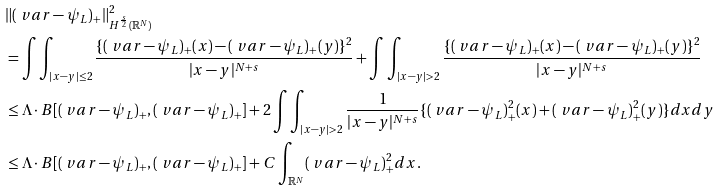<formula> <loc_0><loc_0><loc_500><loc_500>& \| ( \ v a r - \psi _ { L } ) _ { + } \| _ { H ^ { \frac { s } { 2 } } ( \mathbb { R } ^ { N } ) } ^ { 2 } \\ & = \int \int _ { | x - y | \leq 2 } \frac { \{ ( \ v a r - \psi _ { L } ) _ { + } ( x ) - ( \ v a r - \psi _ { L } ) _ { + } ( y ) \} ^ { 2 } } { | x - y | ^ { N + s } } + \int \int _ { | x - y | > 2 } \frac { \{ ( \ v a r - \psi _ { L } ) _ { + } ( x ) - ( \ v a r - \psi _ { L } ) _ { + } ( y ) \} ^ { 2 } } { | x - y | ^ { N + s } } \\ & \leq \Lambda \cdot B [ ( \ v a r - \psi _ { L } ) _ { + } , ( \ v a r - \psi _ { L } ) _ { + } ] + 2 \int \int _ { | x - y | > 2 } \frac { 1 } { | x - y | ^ { N + s } } \{ ( \ v a r - \psi _ { L } ) _ { + } ^ { 2 } ( x ) + ( \ v a r - \psi _ { L } ) _ { + } ^ { 2 } ( y ) \} d x d y \\ & \leq \Lambda \cdot B [ ( \ v a r - \psi _ { L } ) _ { + } , ( \ v a r - \psi _ { L } ) _ { + } ] + C \int _ { \mathbb { R } ^ { N } } ( \ v a r - \psi _ { L } ) _ { + } ^ { 2 } d x .</formula> 